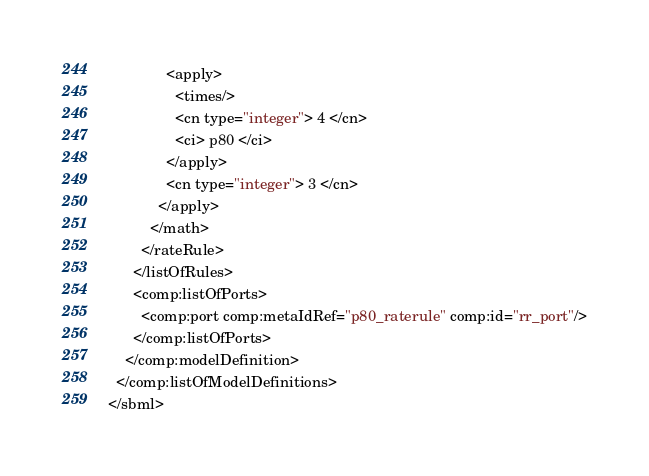<code> <loc_0><loc_0><loc_500><loc_500><_XML_>              <apply>
                <times/>
                <cn type="integer"> 4 </cn>
                <ci> p80 </ci>
              </apply>
              <cn type="integer"> 3 </cn>
            </apply>
          </math>
        </rateRule>
      </listOfRules>
      <comp:listOfPorts>
        <comp:port comp:metaIdRef="p80_raterule" comp:id="rr_port"/>
      </comp:listOfPorts>
    </comp:modelDefinition>
  </comp:listOfModelDefinitions>
</sbml>
</code> 